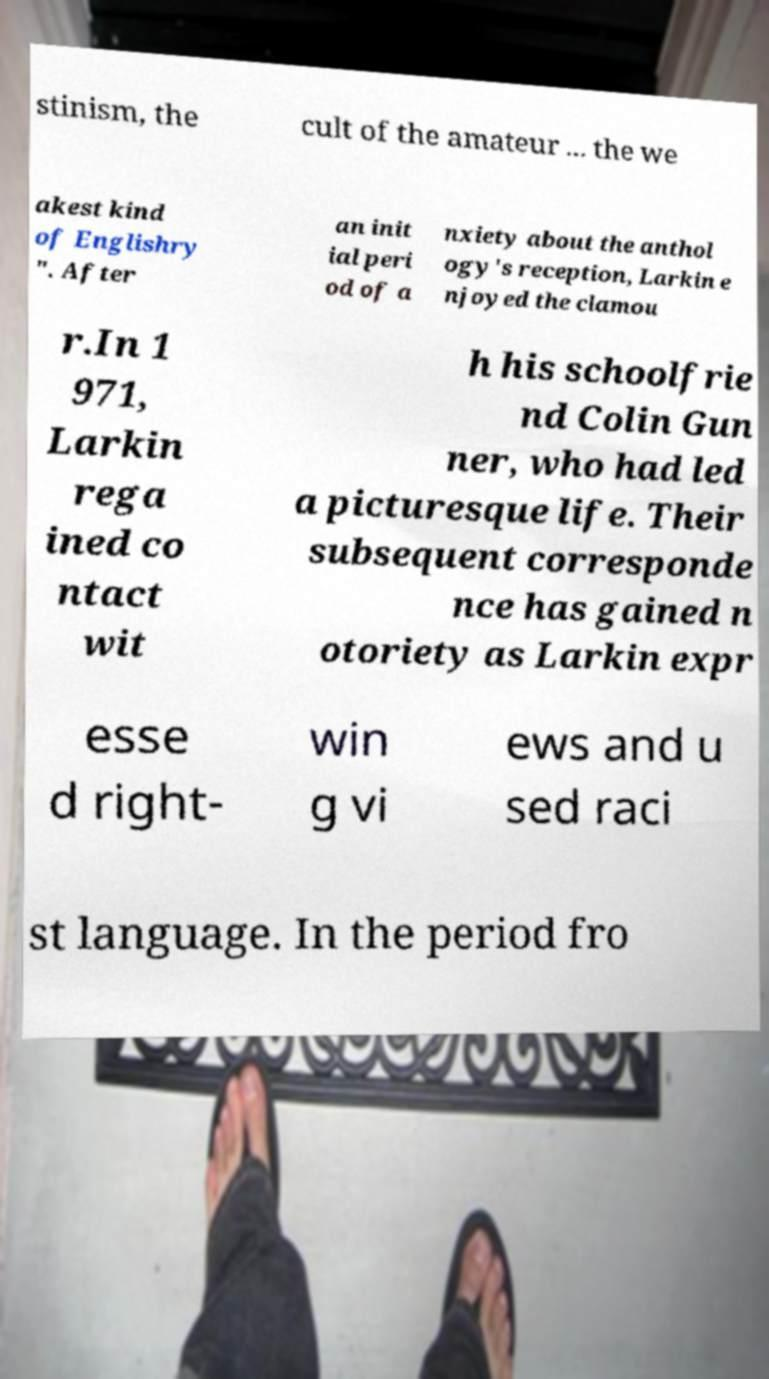Please read and relay the text visible in this image. What does it say? stinism, the cult of the amateur ... the we akest kind of Englishry ". After an init ial peri od of a nxiety about the anthol ogy's reception, Larkin e njoyed the clamou r.In 1 971, Larkin rega ined co ntact wit h his schoolfrie nd Colin Gun ner, who had led a picturesque life. Their subsequent corresponde nce has gained n otoriety as Larkin expr esse d right- win g vi ews and u sed raci st language. In the period fro 